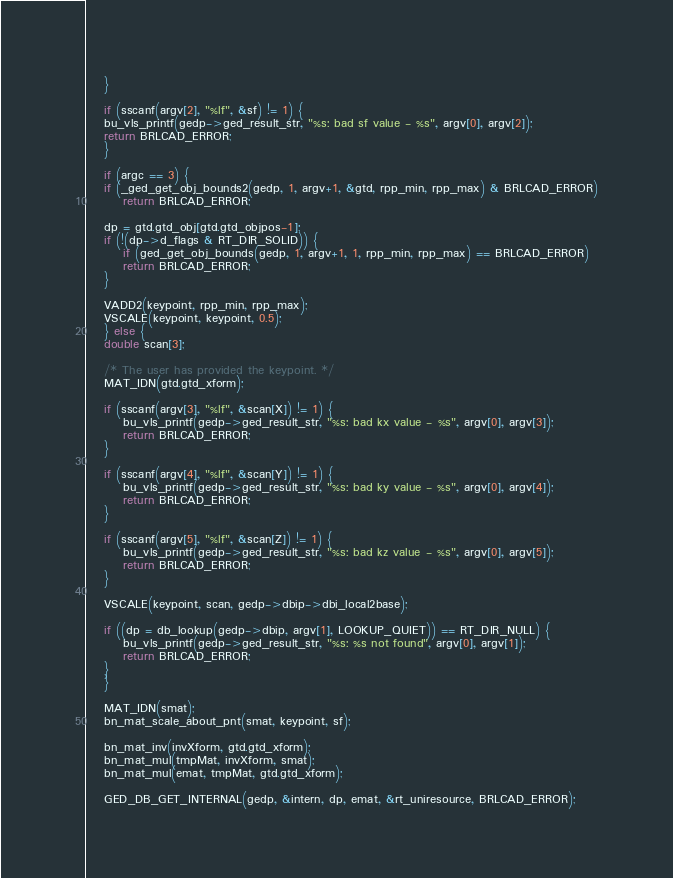Convert code to text. <code><loc_0><loc_0><loc_500><loc_500><_C_>    }

    if (sscanf(argv[2], "%lf", &sf) != 1) {
	bu_vls_printf(gedp->ged_result_str, "%s: bad sf value - %s", argv[0], argv[2]);
	return BRLCAD_ERROR;
    }

    if (argc == 3) {
	if (_ged_get_obj_bounds2(gedp, 1, argv+1, &gtd, rpp_min, rpp_max) & BRLCAD_ERROR)
	    return BRLCAD_ERROR;

	dp = gtd.gtd_obj[gtd.gtd_objpos-1];
	if (!(dp->d_flags & RT_DIR_SOLID)) {
	    if (ged_get_obj_bounds(gedp, 1, argv+1, 1, rpp_min, rpp_max) == BRLCAD_ERROR)
		return BRLCAD_ERROR;
	}

	VADD2(keypoint, rpp_min, rpp_max);
	VSCALE(keypoint, keypoint, 0.5);
    } else {
	double scan[3];

	/* The user has provided the keypoint. */
	MAT_IDN(gtd.gtd_xform);

	if (sscanf(argv[3], "%lf", &scan[X]) != 1) {
	    bu_vls_printf(gedp->ged_result_str, "%s: bad kx value - %s", argv[0], argv[3]);
	    return BRLCAD_ERROR;
	}

	if (sscanf(argv[4], "%lf", &scan[Y]) != 1) {
	    bu_vls_printf(gedp->ged_result_str, "%s: bad ky value - %s", argv[0], argv[4]);
	    return BRLCAD_ERROR;
	}

	if (sscanf(argv[5], "%lf", &scan[Z]) != 1) {
	    bu_vls_printf(gedp->ged_result_str, "%s: bad kz value - %s", argv[0], argv[5]);
	    return BRLCAD_ERROR;
	}

	VSCALE(keypoint, scan, gedp->dbip->dbi_local2base);

	if ((dp = db_lookup(gedp->dbip, argv[1], LOOKUP_QUIET)) == RT_DIR_NULL) {
	    bu_vls_printf(gedp->ged_result_str, "%s: %s not found", argv[0], argv[1]);
	    return BRLCAD_ERROR;
	}
    }

    MAT_IDN(smat);
    bn_mat_scale_about_pnt(smat, keypoint, sf);

    bn_mat_inv(invXform, gtd.gtd_xform);
    bn_mat_mul(tmpMat, invXform, smat);
    bn_mat_mul(emat, tmpMat, gtd.gtd_xform);

    GED_DB_GET_INTERNAL(gedp, &intern, dp, emat, &rt_uniresource, BRLCAD_ERROR);</code> 